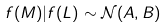Convert formula to latex. <formula><loc_0><loc_0><loc_500><loc_500>f ( M ) | f ( L ) \sim \mathcal { N } ( A , B )</formula> 